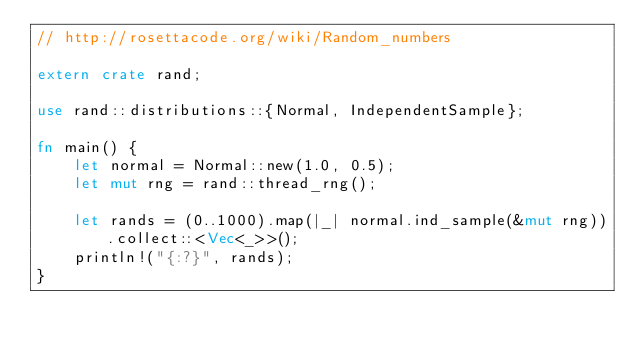<code> <loc_0><loc_0><loc_500><loc_500><_Rust_>// http://rosettacode.org/wiki/Random_numbers

extern crate rand;

use rand::distributions::{Normal, IndependentSample};

fn main() {
    let normal = Normal::new(1.0, 0.5);
    let mut rng = rand::thread_rng();

    let rands = (0..1000).map(|_| normal.ind_sample(&mut rng)).collect::<Vec<_>>();
    println!("{:?}", rands);
}
</code> 